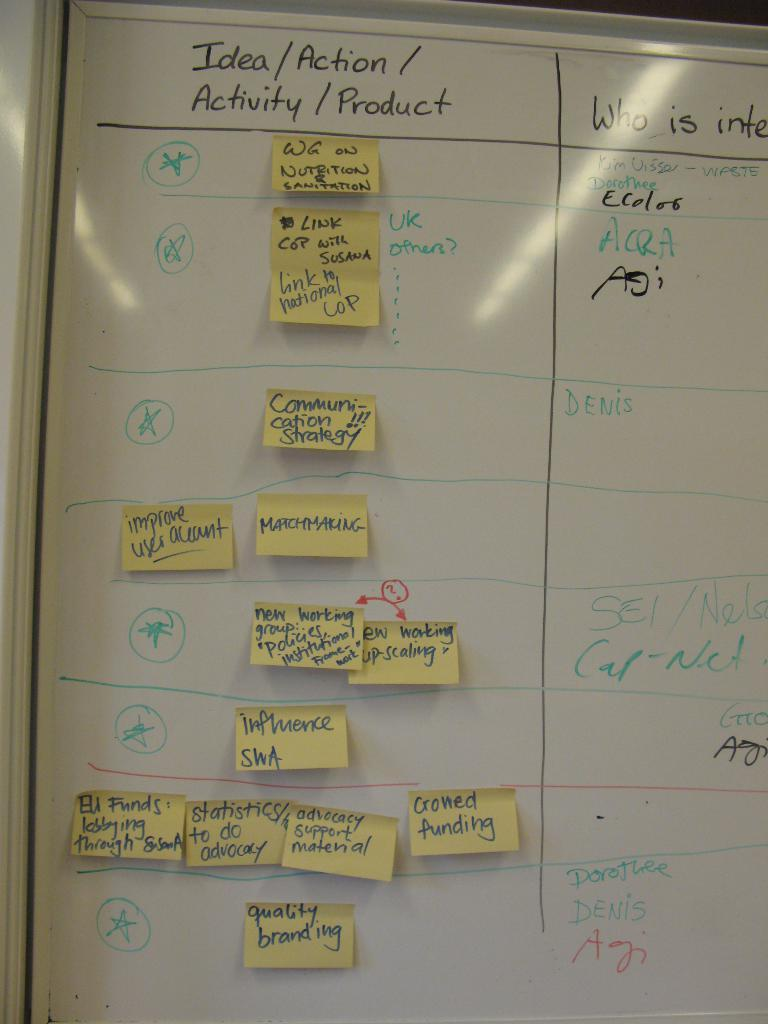Provide a one-sentence caption for the provided image. idea board with different options listed as well as sticky notes. 